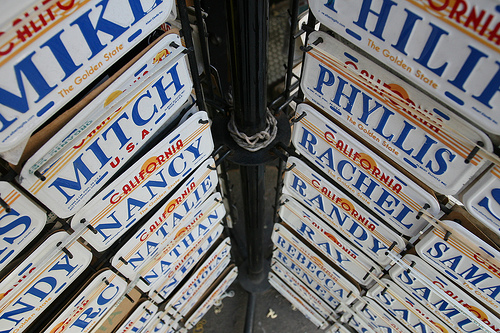<image>
Can you confirm if the nancy plate is on the mitch plate? No. The nancy plate is not positioned on the mitch plate. They may be near each other, but the nancy plate is not supported by or resting on top of the mitch plate. 